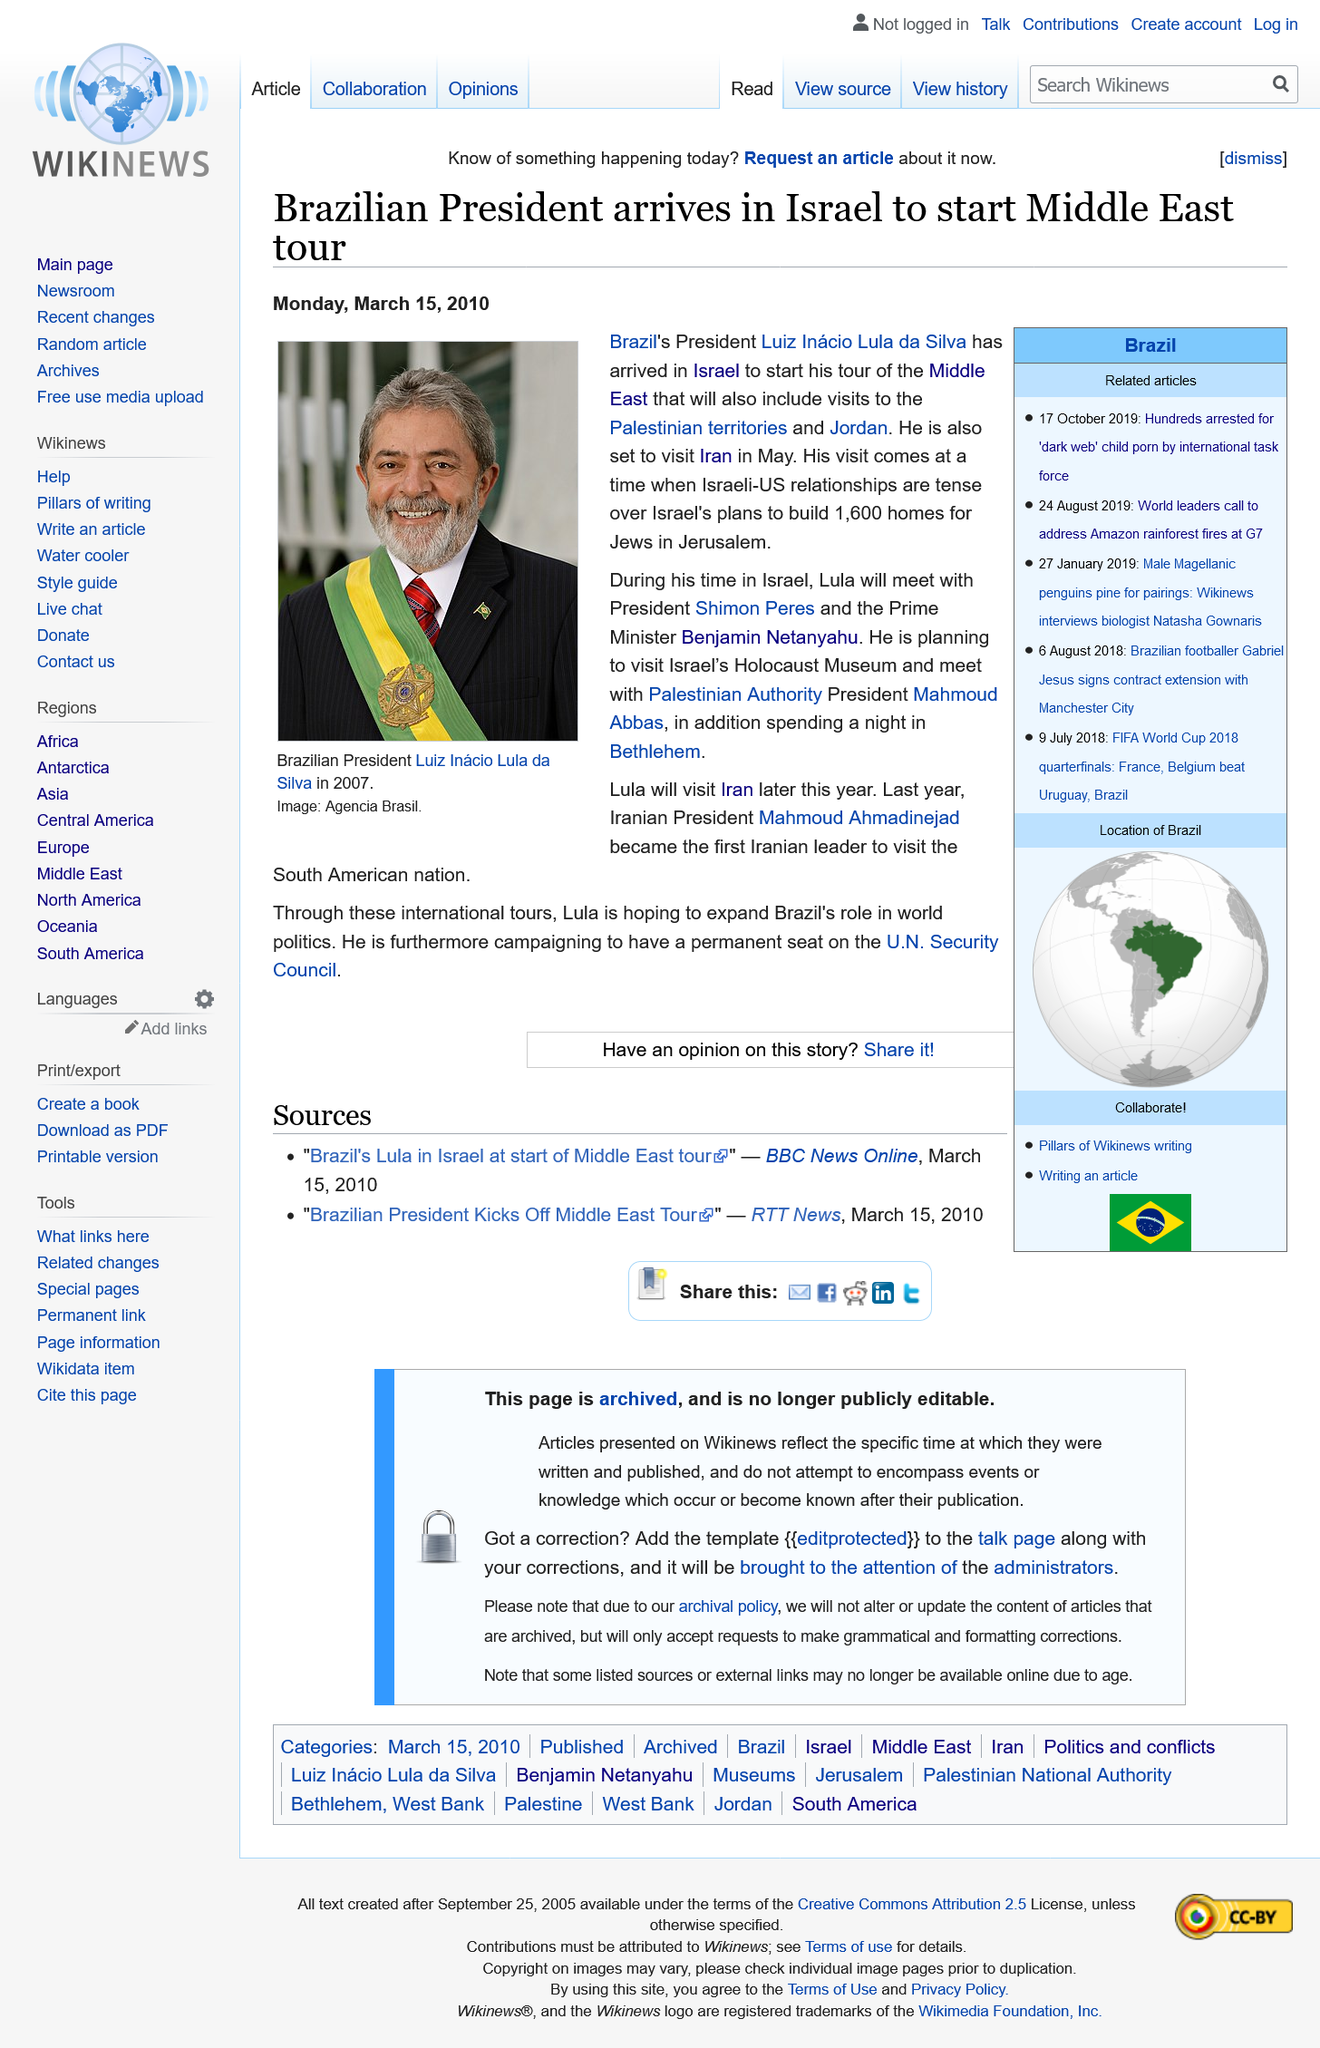Mention a couple of crucial points in this snapshot. Luiz Inacio Lula da Silva is the person who is seen in the photograph. Mahmoud Abbas is the current president of the Palestinian Authority. Mahmoud Ahmadinejad is the president of Iran. 